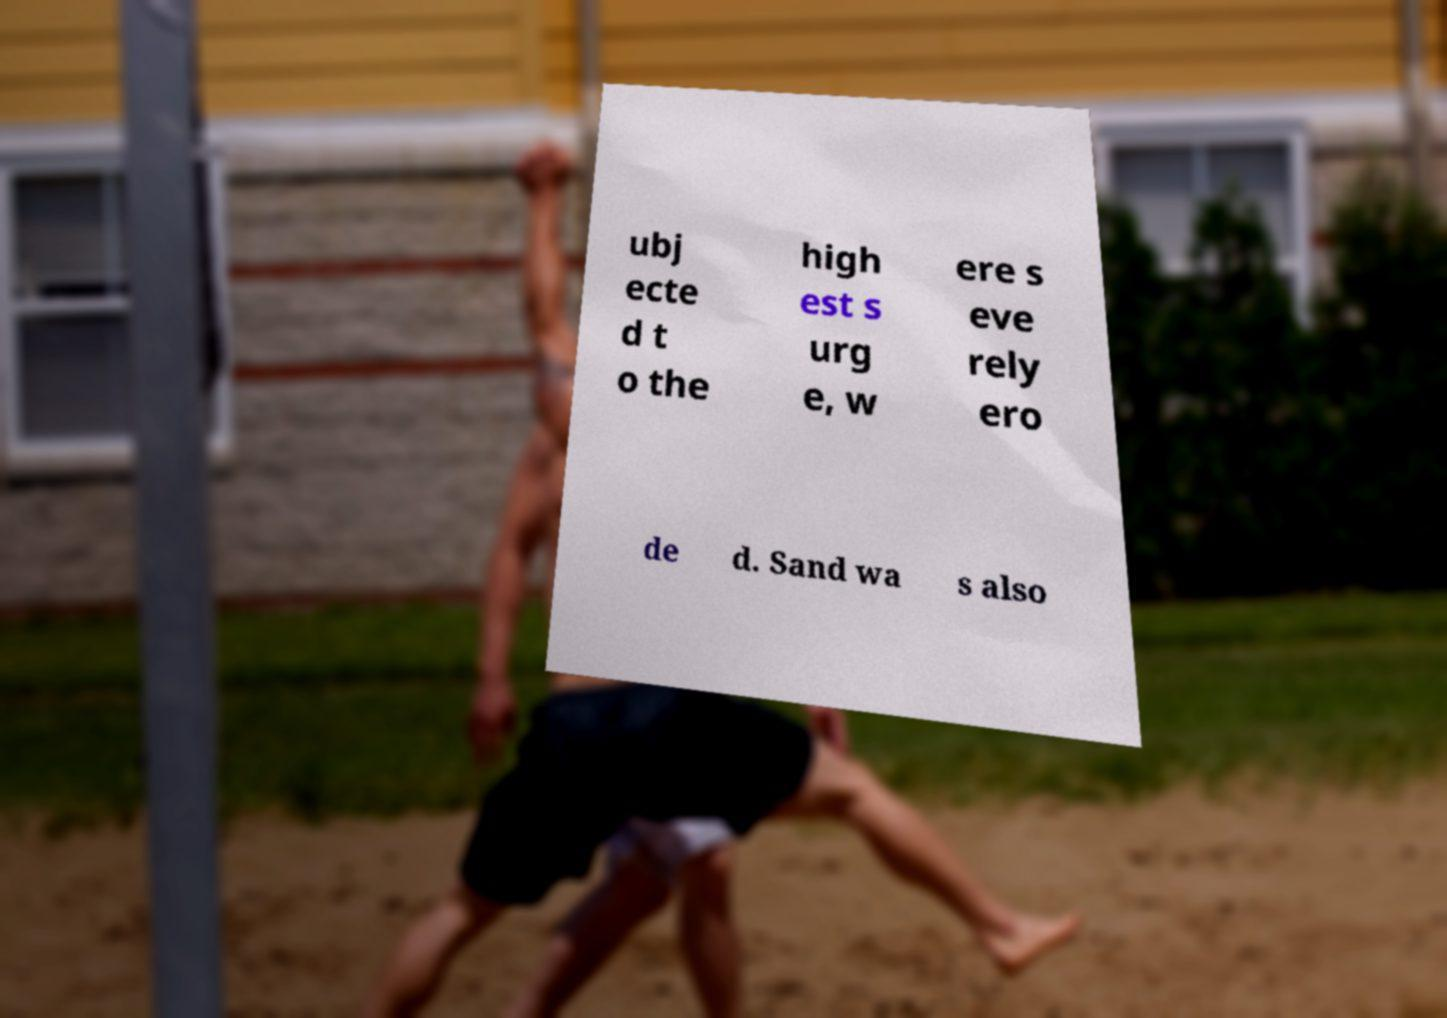Can you accurately transcribe the text from the provided image for me? ubj ecte d t o the high est s urg e, w ere s eve rely ero de d. Sand wa s also 